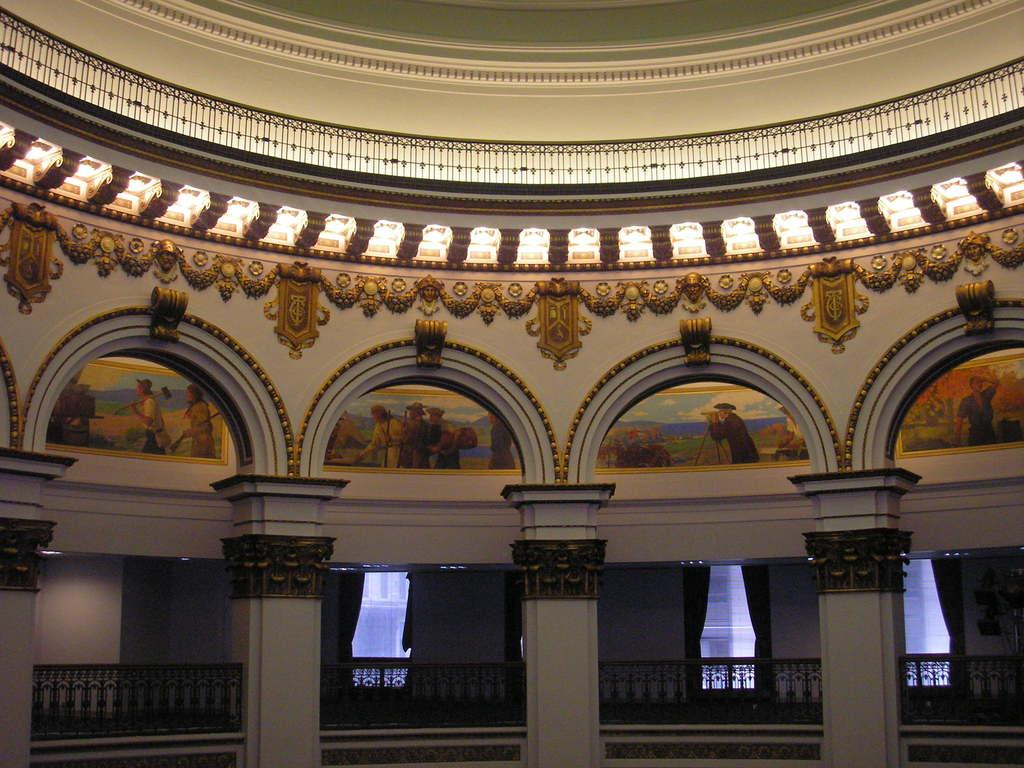What type of location is depicted in the image? The image is an inside view of a building. What architectural feature can be seen in the building? There are arches in the building. What type of decoration is present on the walls of the building? There are paintings on the walls of the building. What is the purpose of the fencing in the image? The fencing in the image extends from left to right, possibly dividing or separating areas within the building. What can be seen at the top of the image? There are lights visible on top in the image. How many people are sitting on the seat in the image? There is no seat present in the image. Can you tell me what type of haircut the person in the image has? There are no people visible in the image, so it is impossible to determine their haircuts. 